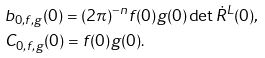Convert formula to latex. <formula><loc_0><loc_0><loc_500><loc_500>& b _ { 0 , f , g } ( 0 ) = ( 2 \pi ) ^ { - n } f ( 0 ) g ( 0 ) \det \dot { R } ^ { L } ( 0 ) , \\ & C _ { 0 , f , g } ( 0 ) = f ( 0 ) g ( 0 ) .</formula> 